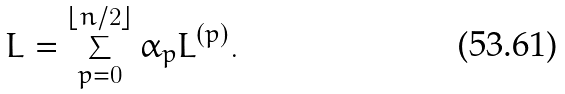<formula> <loc_0><loc_0><loc_500><loc_500>L = \sum _ { p = 0 } ^ { \lfloor n / 2 \rfloor } \alpha _ { p } L ^ { ( p ) } .</formula> 